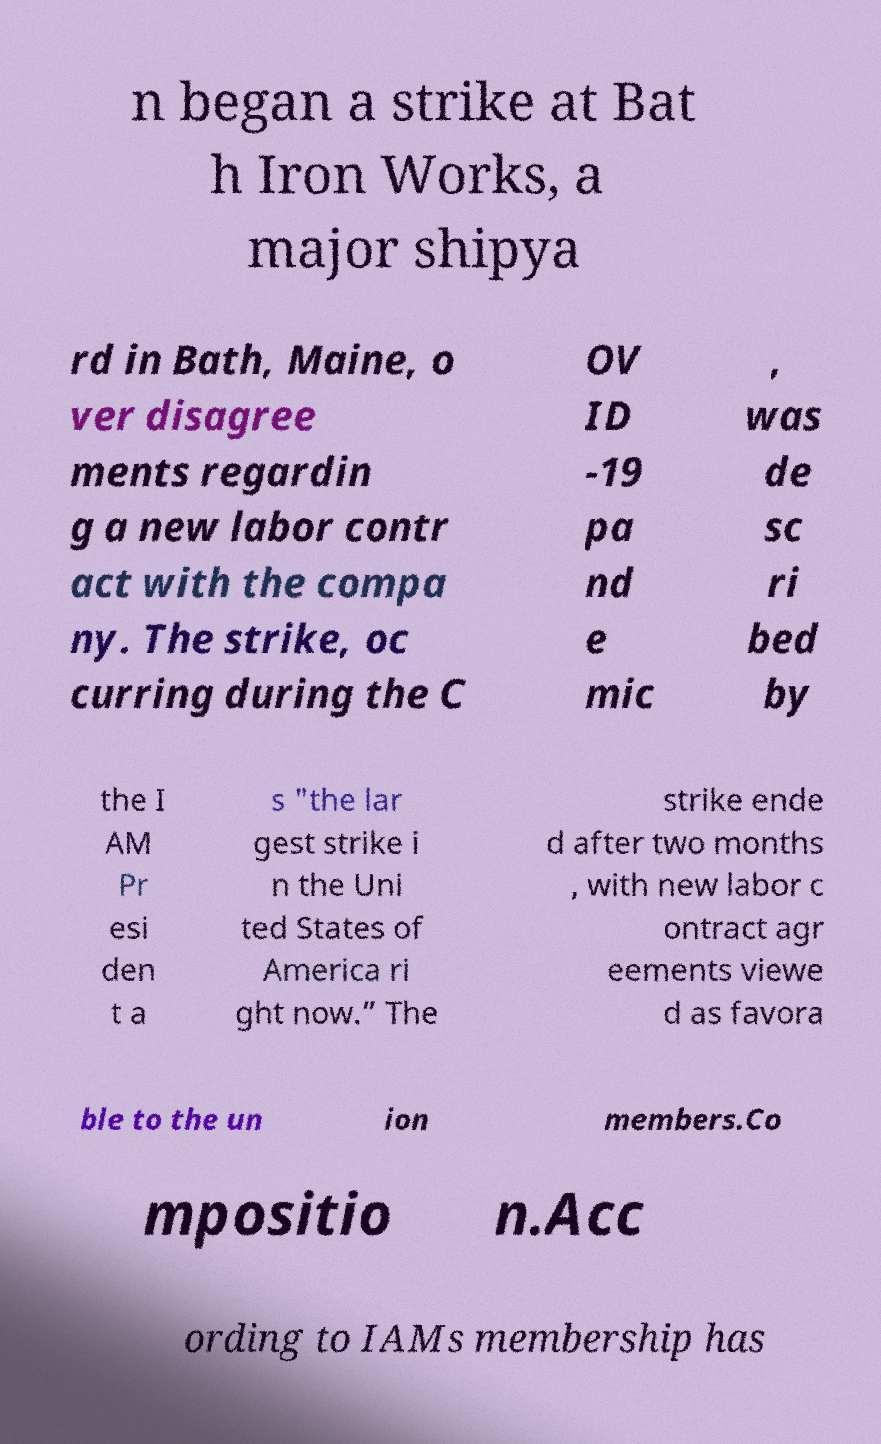What messages or text are displayed in this image? I need them in a readable, typed format. n began a strike at Bat h Iron Works, a major shipya rd in Bath, Maine, o ver disagree ments regardin g a new labor contr act with the compa ny. The strike, oc curring during the C OV ID -19 pa nd e mic , was de sc ri bed by the I AM Pr esi den t a s "the lar gest strike i n the Uni ted States of America ri ght now.” The strike ende d after two months , with new labor c ontract agr eements viewe d as favora ble to the un ion members.Co mpositio n.Acc ording to IAMs membership has 